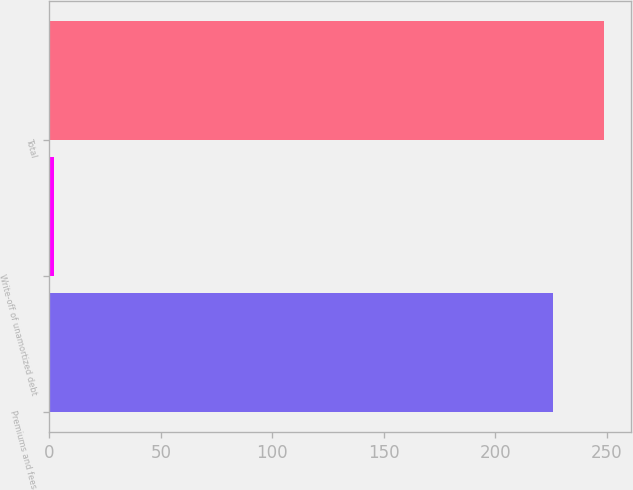Convert chart. <chart><loc_0><loc_0><loc_500><loc_500><bar_chart><fcel>Premiums and fees<fcel>Write-off of unamortized debt<fcel>Total<nl><fcel>226<fcel>2<fcel>248.6<nl></chart> 